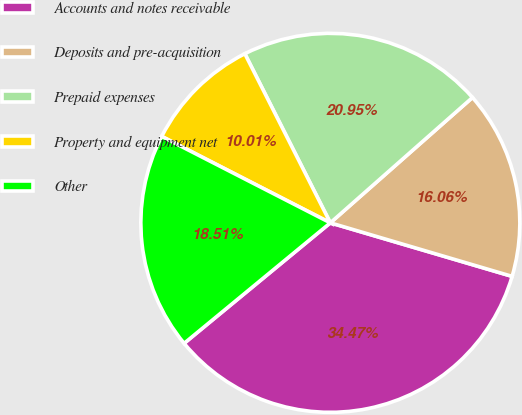Convert chart. <chart><loc_0><loc_0><loc_500><loc_500><pie_chart><fcel>Accounts and notes receivable<fcel>Deposits and pre-acquisition<fcel>Prepaid expenses<fcel>Property and equipment net<fcel>Other<nl><fcel>34.47%<fcel>16.06%<fcel>20.95%<fcel>10.01%<fcel>18.51%<nl></chart> 